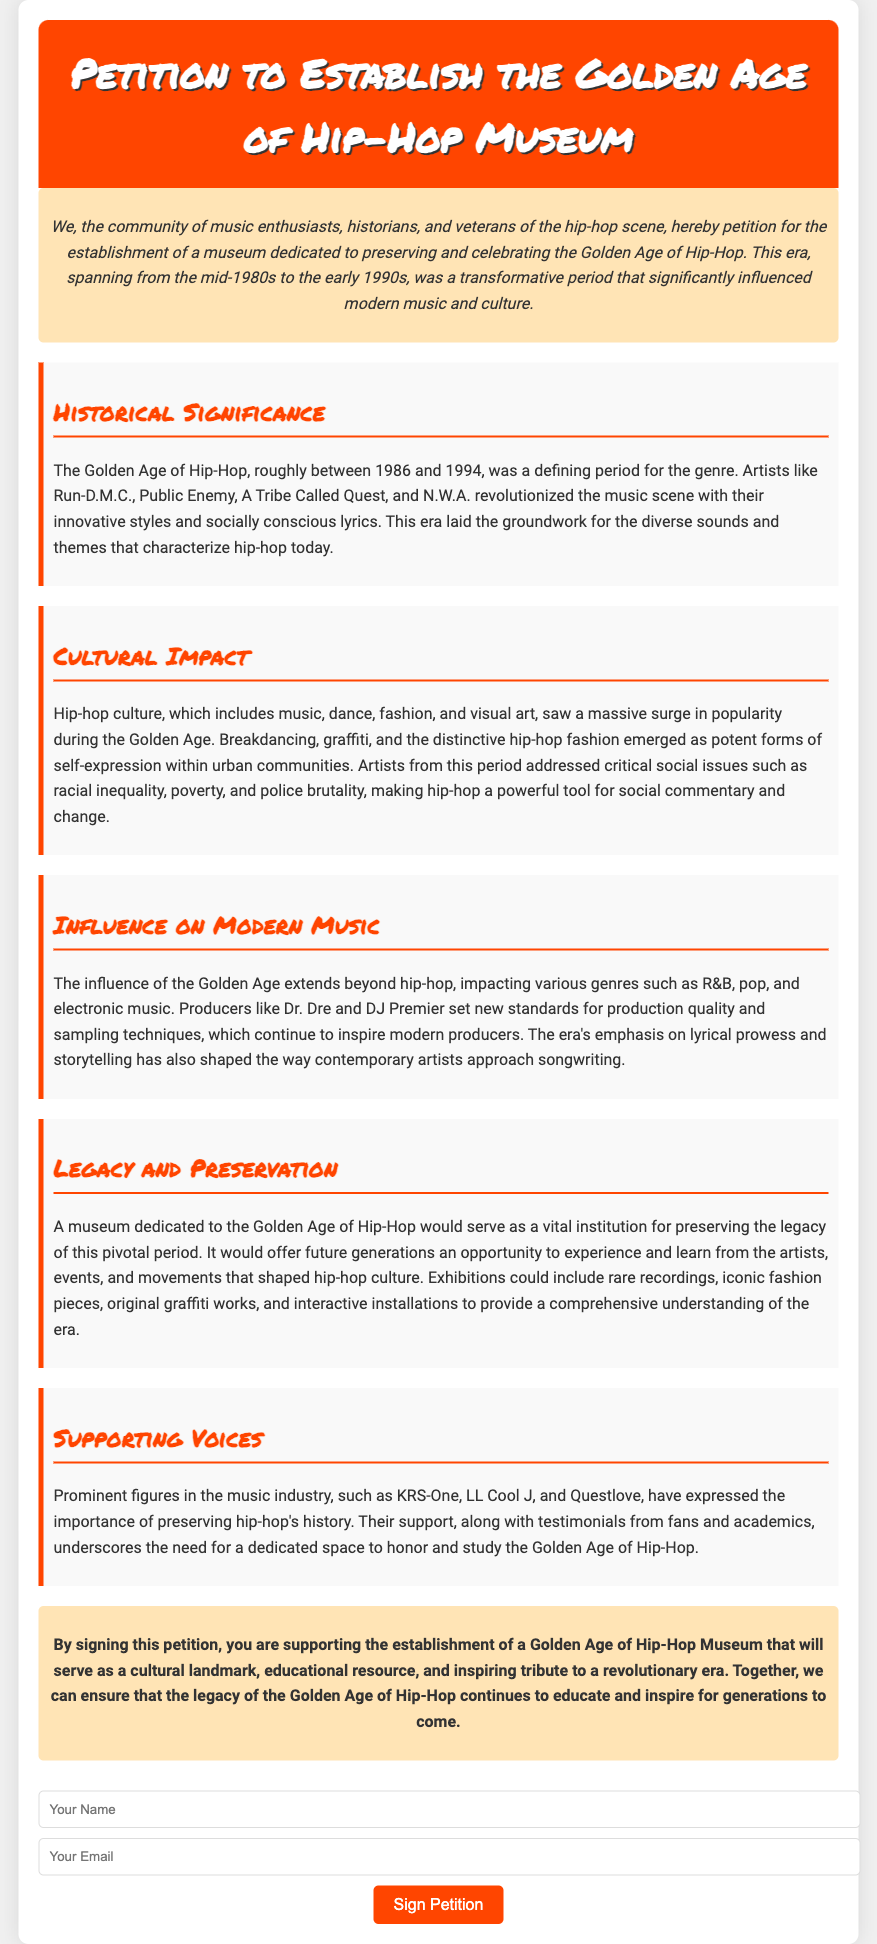What is the title of the petition? The title of the petition is found in the header section, prominently displayed in large font.
Answer: Petition to Establish the Golden Age of Hip-Hop Museum What years define the Golden Age of Hip-Hop? The years that define the Golden Age of Hip-Hop are mentioned in the section on Historical Significance.
Answer: 1986 to 1994 Which artists are highlighted as influential during the Golden Age of Hip-Hop? The document lists artists like Run-D.M.C., Public Enemy, A Tribe Called Quest, and N.W.A. in the historical section.
Answer: Run-D.M.C., Public Enemy, A Tribe Called Quest, N.W.A What cultural aspects surged in popularity during this era? The section on Cultural Impact details the elements related to hip-hop culture that gained prominence.
Answer: Breakdancing, graffiti, hip-hop fashion Who are some of the prominent figures supporting the establishment of this museum? The Supporting Voices section mentions KRS-One, LL Cool J, and Questlove as advocates for preserving hip-hop history.
Answer: KRS-One, LL Cool J, Questlove What key purpose does the museum aim to serve according to the petition? The conclusion of the document highlights the main purpose of the museum.
Answer: Cultural landmark, educational resource, tribute What type of exhibitions could be included in the museum? The Legacy and Preservation section suggests various types of items and formats for exhibitions.
Answer: Rare recordings, iconic fashion pieces, original graffiti works How many sections are included in the petition? The document has a total of six sections, including the introduction and conclusion, which can be counted.
Answer: 6 